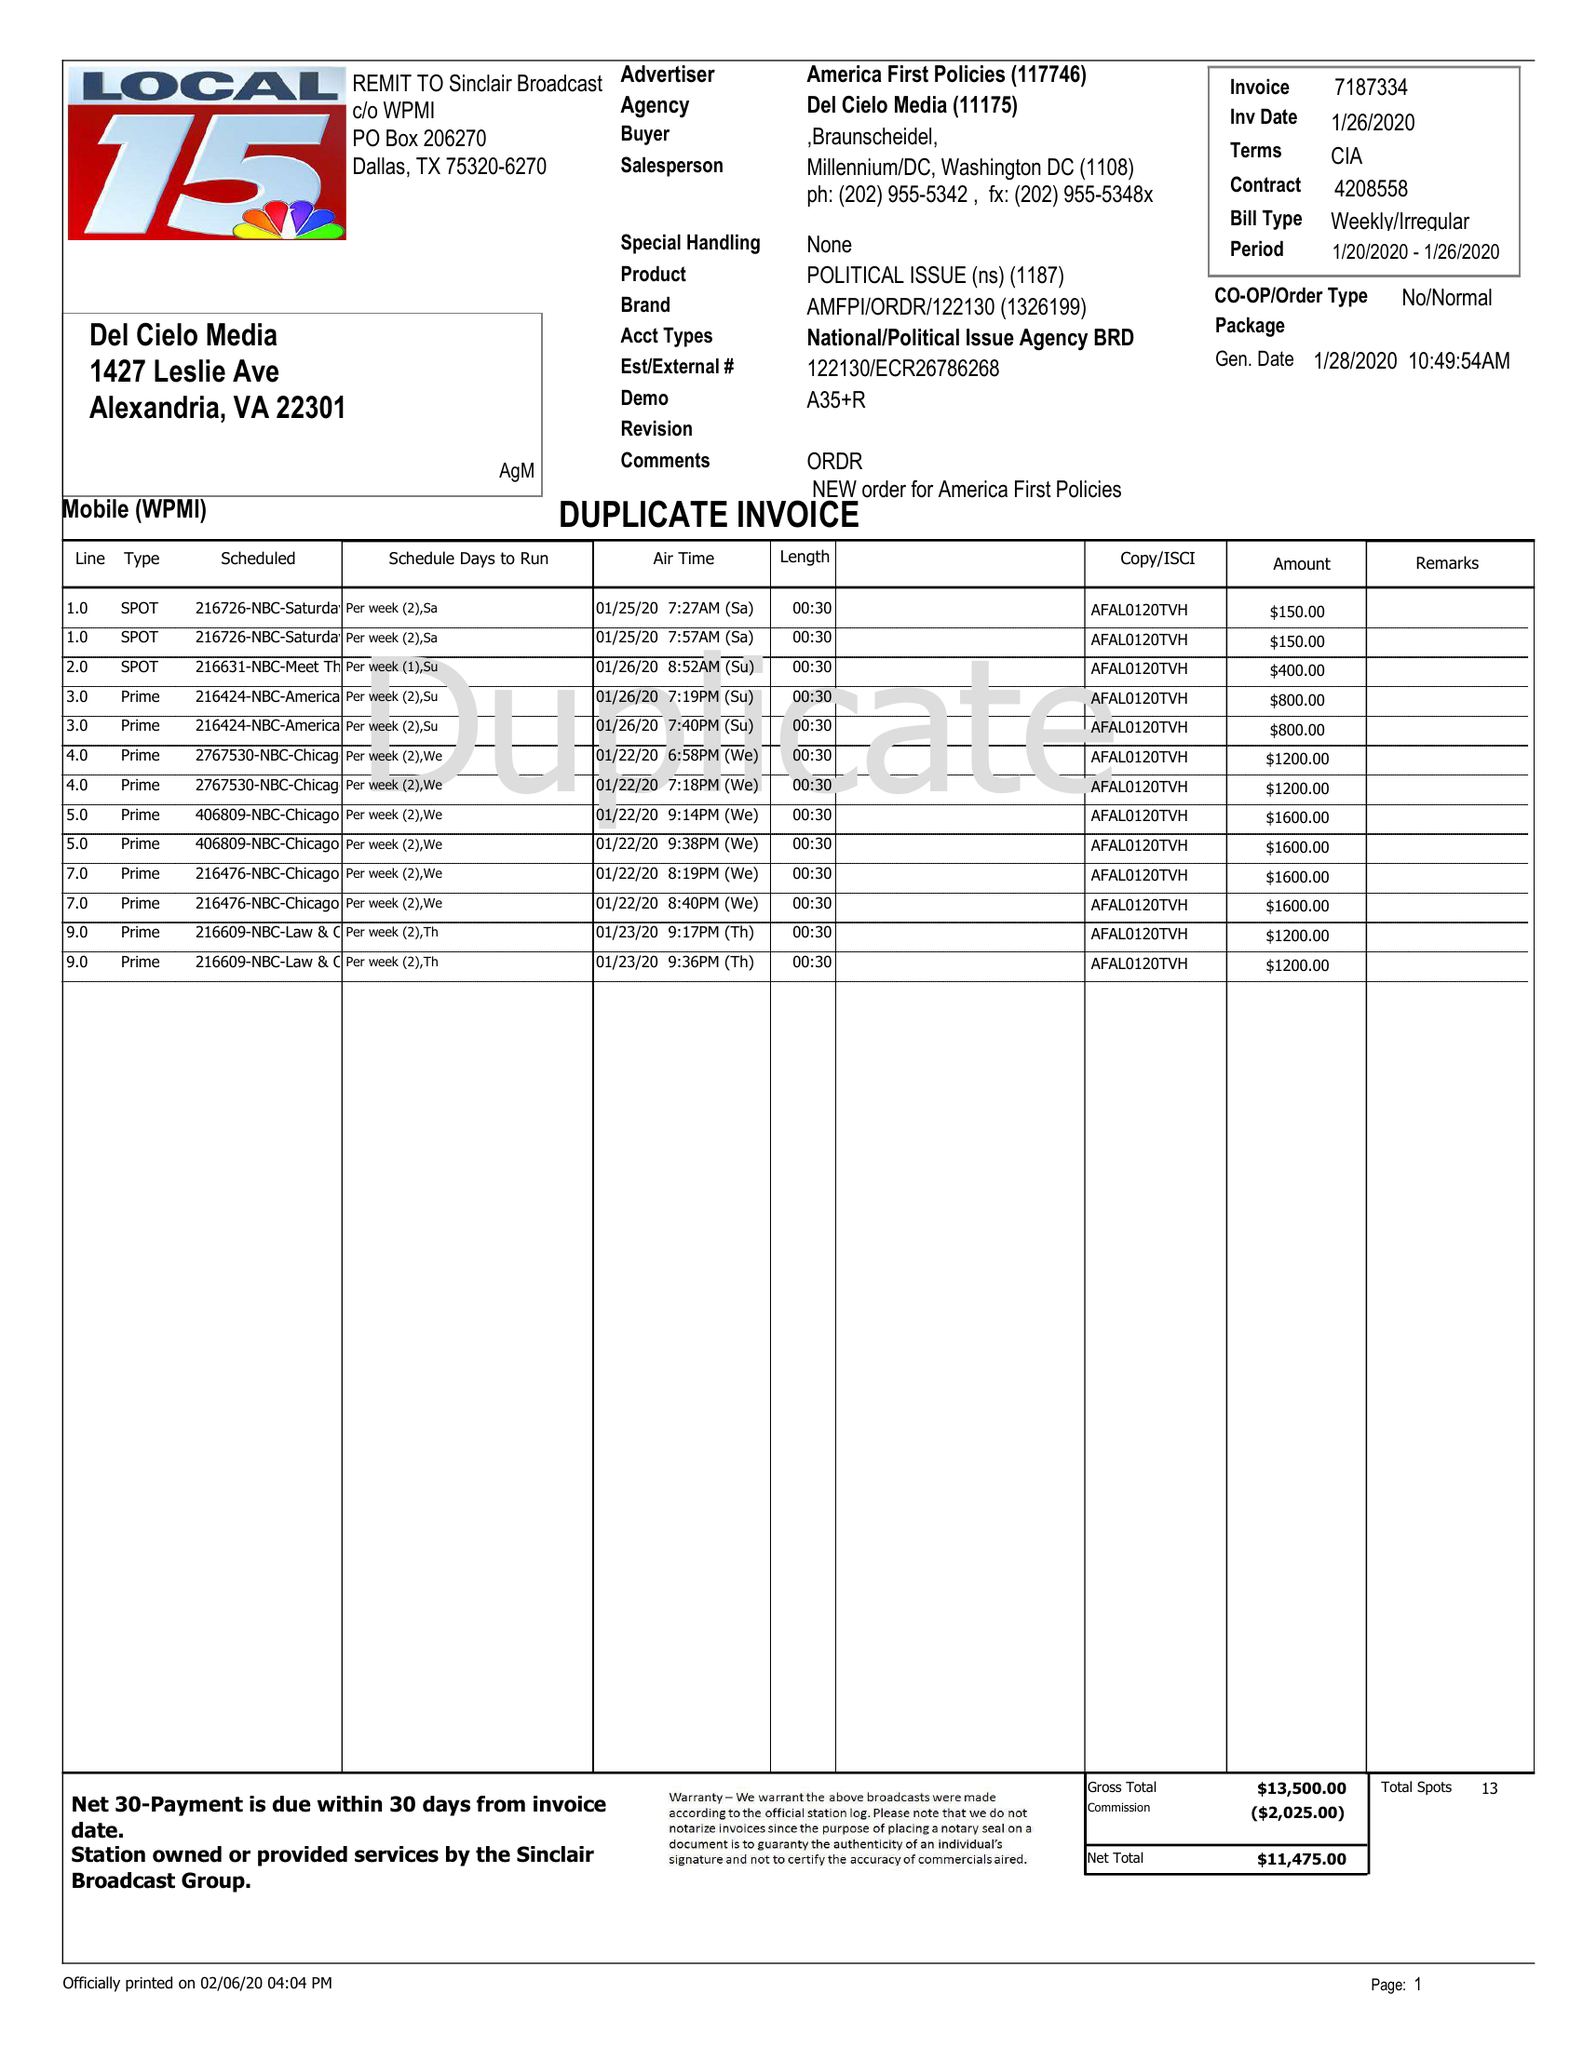What is the value for the gross_amount?
Answer the question using a single word or phrase. 23100.00 